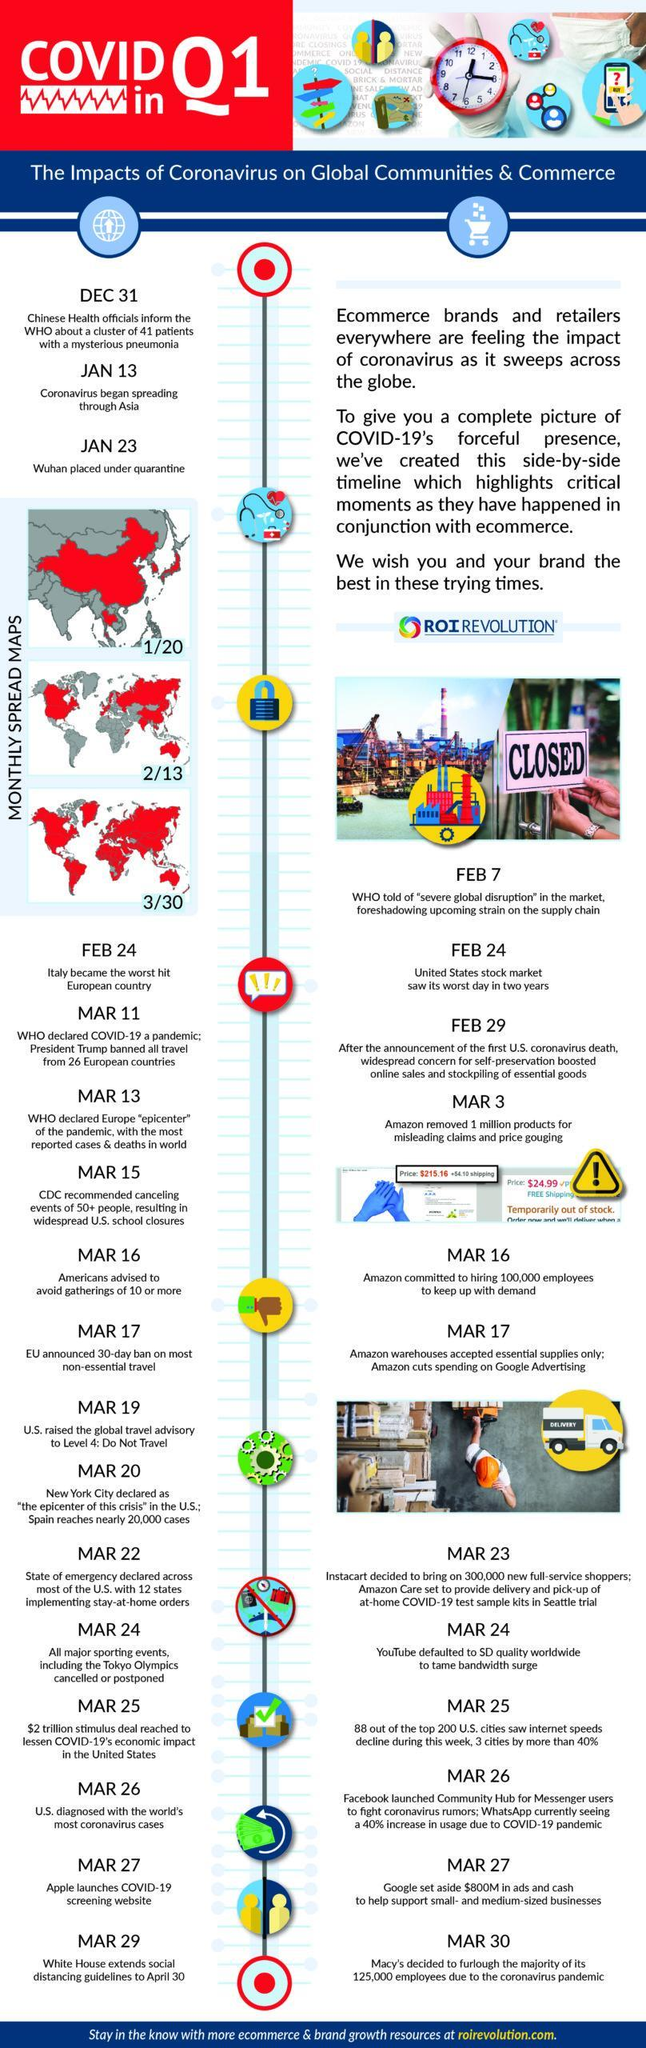When did Apple launched COVID-19 screening website?
Answer the question with a short phrase. MAR 27 When did Amazon removed one million products for misleading claims & price gouging? MAR 3 When did EU announced a 30 day ban on most non-essential travel? MAR 17 